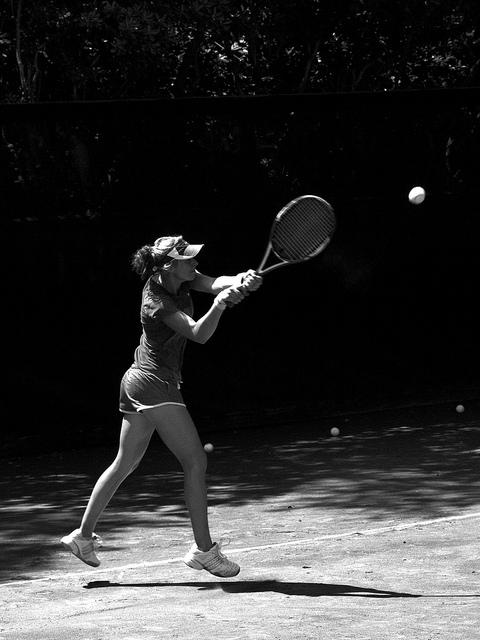Is the girl in mid-jump?
Answer briefly. Yes. What sport is she playing?
Quick response, please. Tennis. Is there a frisbee?
Keep it brief. No. How many athletes are featured in this picture?
Be succinct. 1. Is the girl wearing pants?
Be succinct. No. 